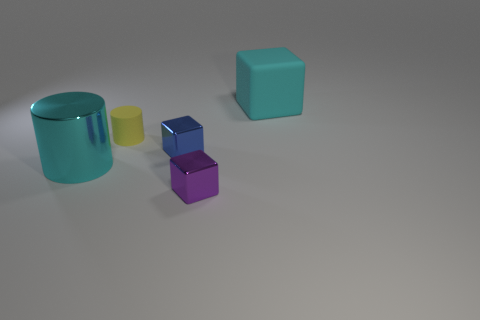Subtract all rubber cubes. How many cubes are left? 2 Add 4 tiny purple shiny cubes. How many objects exist? 9 Subtract 2 blocks. How many blocks are left? 1 Subtract all cylinders. How many objects are left? 3 Subtract all blue blocks. Subtract all yellow cylinders. How many blocks are left? 2 Subtract all blue cylinders. How many cyan cubes are left? 1 Subtract all big cyan cylinders. Subtract all big cyan objects. How many objects are left? 2 Add 4 purple objects. How many purple objects are left? 5 Add 4 blue metal cubes. How many blue metal cubes exist? 5 Subtract all yellow cylinders. How many cylinders are left? 1 